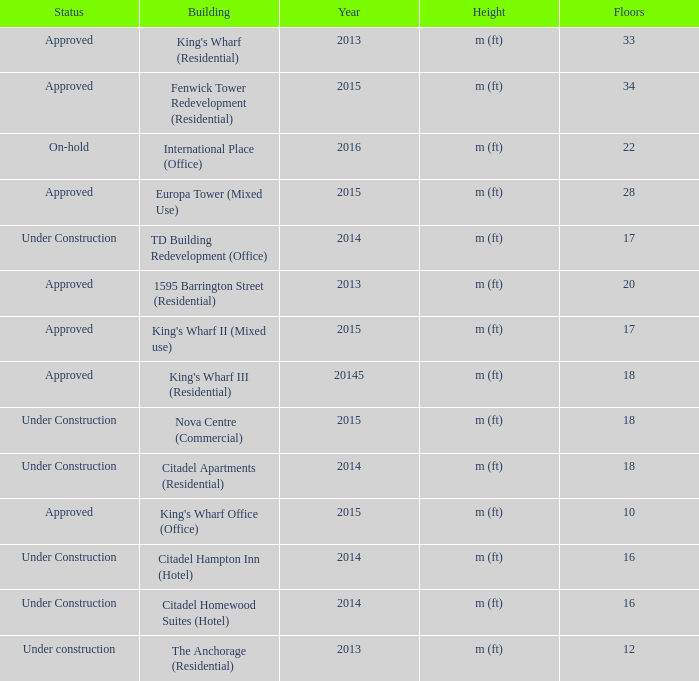What building shows 2013 and has more than 20 floors? King's Wharf (Residential). 